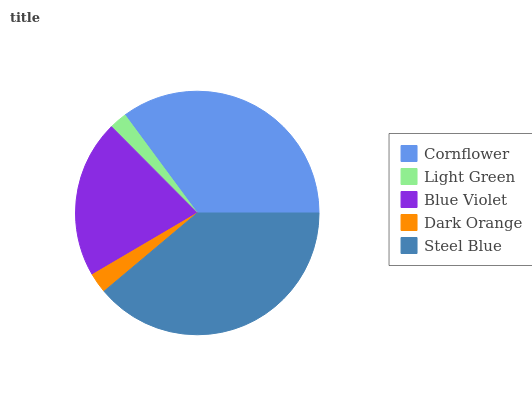Is Light Green the minimum?
Answer yes or no. Yes. Is Steel Blue the maximum?
Answer yes or no. Yes. Is Blue Violet the minimum?
Answer yes or no. No. Is Blue Violet the maximum?
Answer yes or no. No. Is Blue Violet greater than Light Green?
Answer yes or no. Yes. Is Light Green less than Blue Violet?
Answer yes or no. Yes. Is Light Green greater than Blue Violet?
Answer yes or no. No. Is Blue Violet less than Light Green?
Answer yes or no. No. Is Blue Violet the high median?
Answer yes or no. Yes. Is Blue Violet the low median?
Answer yes or no. Yes. Is Steel Blue the high median?
Answer yes or no. No. Is Steel Blue the low median?
Answer yes or no. No. 